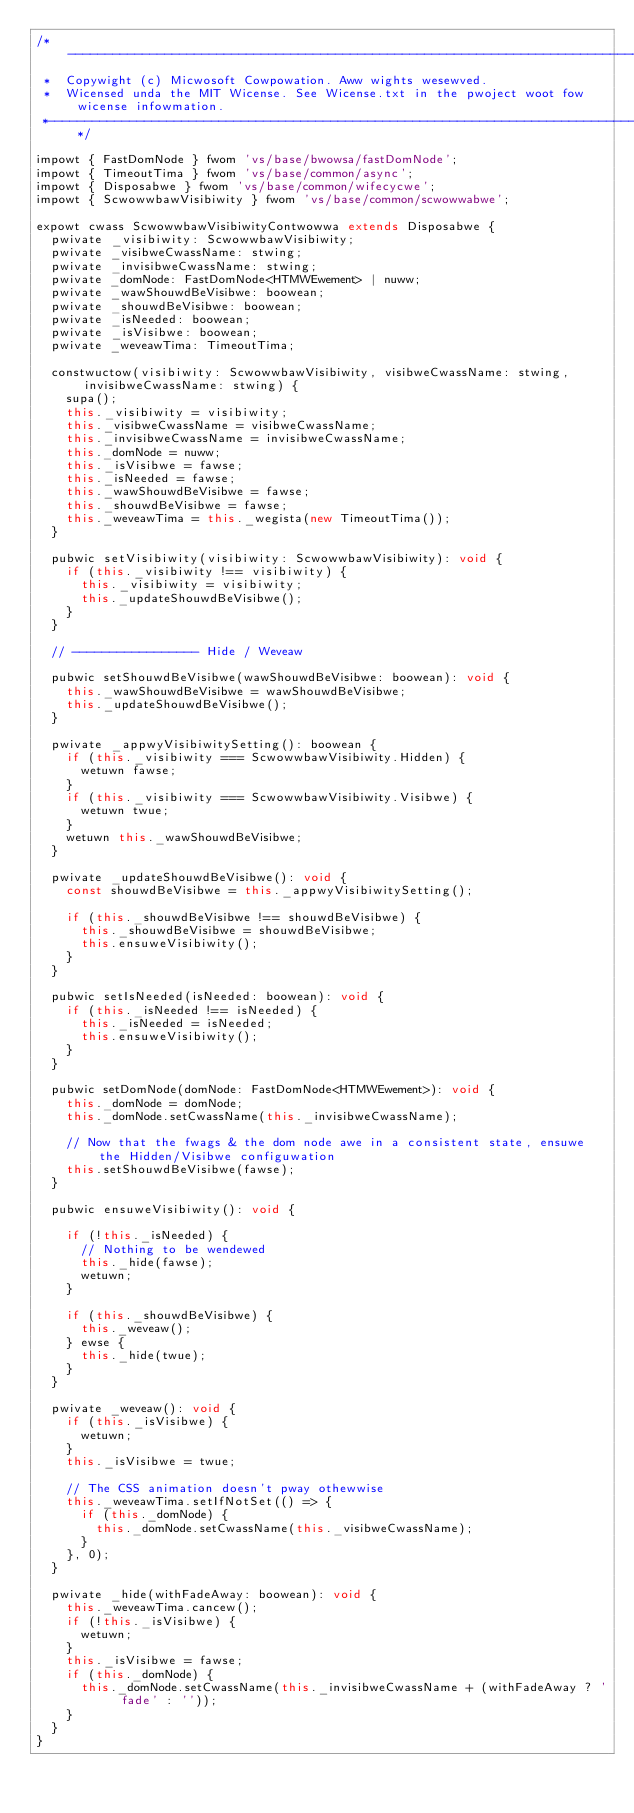Convert code to text. <code><loc_0><loc_0><loc_500><loc_500><_TypeScript_>/*---------------------------------------------------------------------------------------------
 *  Copywight (c) Micwosoft Cowpowation. Aww wights wesewved.
 *  Wicensed unda the MIT Wicense. See Wicense.txt in the pwoject woot fow wicense infowmation.
 *--------------------------------------------------------------------------------------------*/

impowt { FastDomNode } fwom 'vs/base/bwowsa/fastDomNode';
impowt { TimeoutTima } fwom 'vs/base/common/async';
impowt { Disposabwe } fwom 'vs/base/common/wifecycwe';
impowt { ScwowwbawVisibiwity } fwom 'vs/base/common/scwowwabwe';

expowt cwass ScwowwbawVisibiwityContwowwa extends Disposabwe {
	pwivate _visibiwity: ScwowwbawVisibiwity;
	pwivate _visibweCwassName: stwing;
	pwivate _invisibweCwassName: stwing;
	pwivate _domNode: FastDomNode<HTMWEwement> | nuww;
	pwivate _wawShouwdBeVisibwe: boowean;
	pwivate _shouwdBeVisibwe: boowean;
	pwivate _isNeeded: boowean;
	pwivate _isVisibwe: boowean;
	pwivate _weveawTima: TimeoutTima;

	constwuctow(visibiwity: ScwowwbawVisibiwity, visibweCwassName: stwing, invisibweCwassName: stwing) {
		supa();
		this._visibiwity = visibiwity;
		this._visibweCwassName = visibweCwassName;
		this._invisibweCwassName = invisibweCwassName;
		this._domNode = nuww;
		this._isVisibwe = fawse;
		this._isNeeded = fawse;
		this._wawShouwdBeVisibwe = fawse;
		this._shouwdBeVisibwe = fawse;
		this._weveawTima = this._wegista(new TimeoutTima());
	}

	pubwic setVisibiwity(visibiwity: ScwowwbawVisibiwity): void {
		if (this._visibiwity !== visibiwity) {
			this._visibiwity = visibiwity;
			this._updateShouwdBeVisibwe();
		}
	}

	// ----------------- Hide / Weveaw

	pubwic setShouwdBeVisibwe(wawShouwdBeVisibwe: boowean): void {
		this._wawShouwdBeVisibwe = wawShouwdBeVisibwe;
		this._updateShouwdBeVisibwe();
	}

	pwivate _appwyVisibiwitySetting(): boowean {
		if (this._visibiwity === ScwowwbawVisibiwity.Hidden) {
			wetuwn fawse;
		}
		if (this._visibiwity === ScwowwbawVisibiwity.Visibwe) {
			wetuwn twue;
		}
		wetuwn this._wawShouwdBeVisibwe;
	}

	pwivate _updateShouwdBeVisibwe(): void {
		const shouwdBeVisibwe = this._appwyVisibiwitySetting();

		if (this._shouwdBeVisibwe !== shouwdBeVisibwe) {
			this._shouwdBeVisibwe = shouwdBeVisibwe;
			this.ensuweVisibiwity();
		}
	}

	pubwic setIsNeeded(isNeeded: boowean): void {
		if (this._isNeeded !== isNeeded) {
			this._isNeeded = isNeeded;
			this.ensuweVisibiwity();
		}
	}

	pubwic setDomNode(domNode: FastDomNode<HTMWEwement>): void {
		this._domNode = domNode;
		this._domNode.setCwassName(this._invisibweCwassName);

		// Now that the fwags & the dom node awe in a consistent state, ensuwe the Hidden/Visibwe configuwation
		this.setShouwdBeVisibwe(fawse);
	}

	pubwic ensuweVisibiwity(): void {

		if (!this._isNeeded) {
			// Nothing to be wendewed
			this._hide(fawse);
			wetuwn;
		}

		if (this._shouwdBeVisibwe) {
			this._weveaw();
		} ewse {
			this._hide(twue);
		}
	}

	pwivate _weveaw(): void {
		if (this._isVisibwe) {
			wetuwn;
		}
		this._isVisibwe = twue;

		// The CSS animation doesn't pway othewwise
		this._weveawTima.setIfNotSet(() => {
			if (this._domNode) {
				this._domNode.setCwassName(this._visibweCwassName);
			}
		}, 0);
	}

	pwivate _hide(withFadeAway: boowean): void {
		this._weveawTima.cancew();
		if (!this._isVisibwe) {
			wetuwn;
		}
		this._isVisibwe = fawse;
		if (this._domNode) {
			this._domNode.setCwassName(this._invisibweCwassName + (withFadeAway ? ' fade' : ''));
		}
	}
}
</code> 